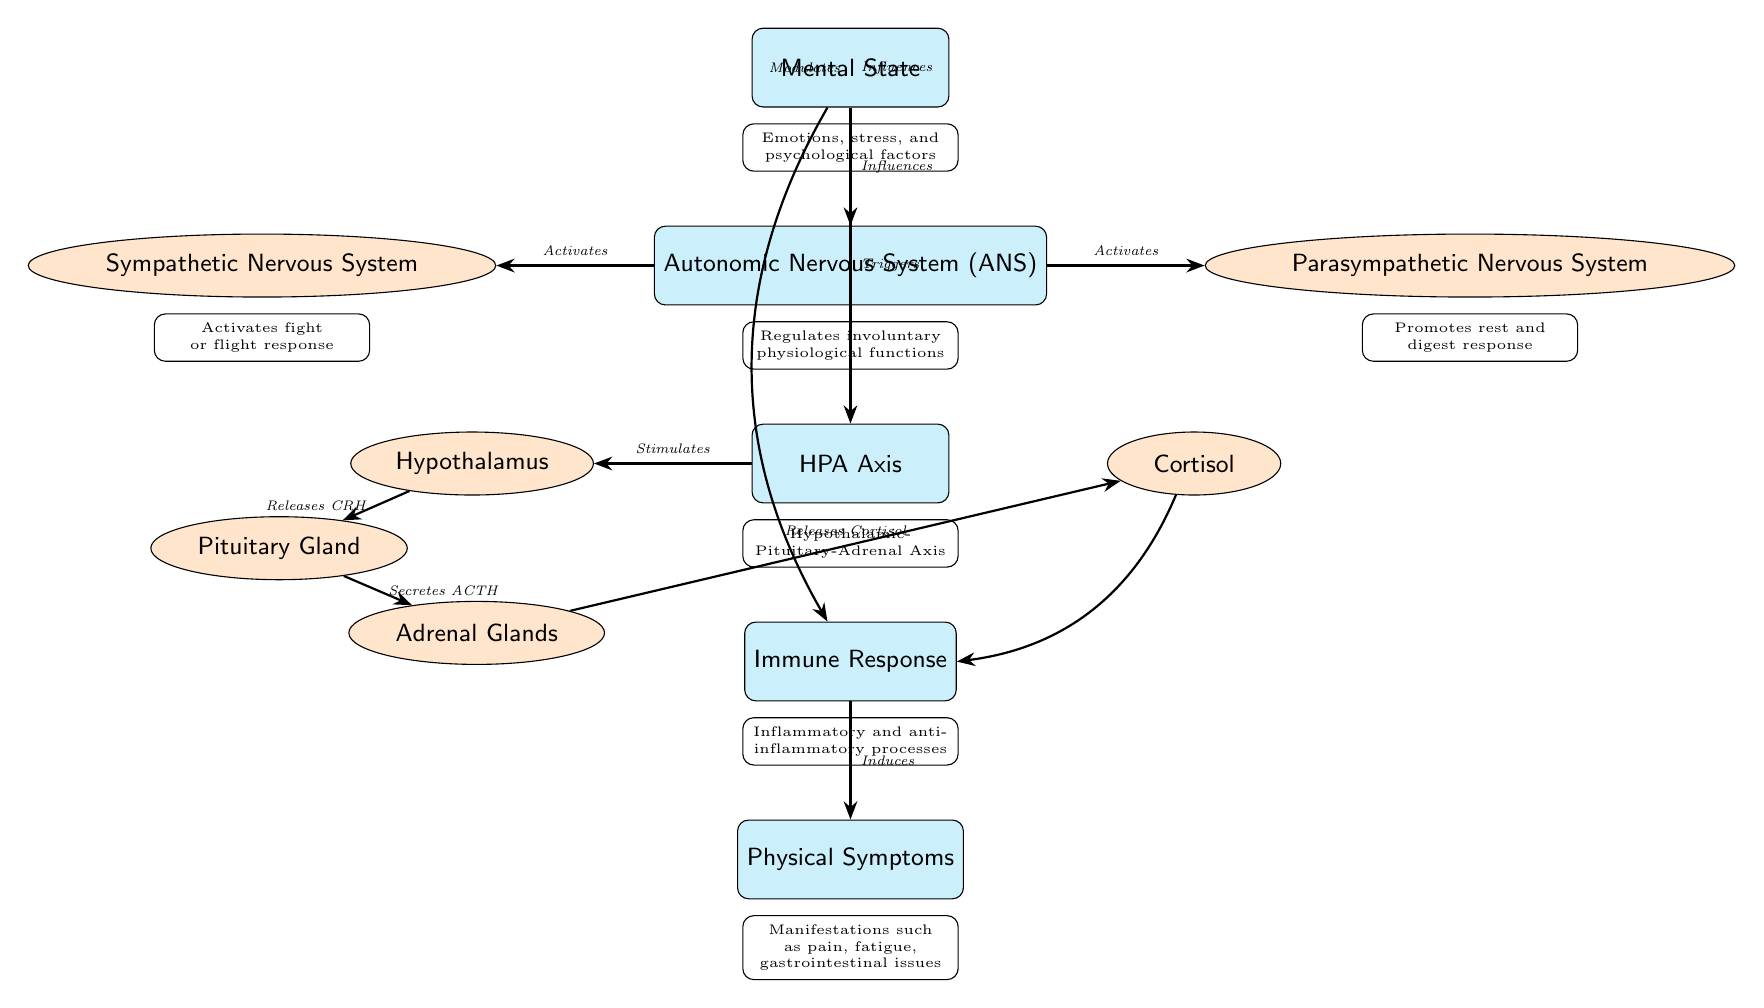What influences the Autonomic Nervous System? The diagram shows an arrow from the Mental State node to the Autonomic Nervous System node, labeled "Influences," indicating that mental states affect the ANS.
Answer: Mental State Which system activates the fight or flight response? Looking at the sub-node of the Autonomic Nervous System, the Sympathetic Nervous System is indicated as activating this response.
Answer: Sympathetic Nervous System What does the HPA axis stimulate? The diagram connects the HPA Axis to the Hypothalamus with a labeled arrow indicating it "Stimulates," suggesting that the HPA axis’s role is to activate the hypothalamus.
Answer: Hypothalamus How do mental states affect immune responses? The diagram shows a curved arrow connecting the Mental State to the Immune Response with the label "Modulates," indicating that mental states can influence or adjust immune functioning.
Answer: Modulates Which gland secretes ACTH? Following the arrows in the diagram, it is clear that ACTH is secreted by the Pituitary Gland as shown in the flow from the Hypothalamus to the Pituitary.
Answer: Pituitary Gland What is the outcome of the immune response on physical symptoms? The diagram shows that the Immune Response induces Physical Symptoms, clearly illustrating a direct connection.
Answer: Induces What hormone is released by the adrenal glands? The diagram specifies that the Adrenal Glands release Cortisol, indicating a straightforward hormonal relationship represented in the flow.
Answer: Cortisol Which branch of the autonomic nervous system promotes rest and digest responses? The diagram identifies the Parasympathetic Nervous System as responsible for promoting this response, as indicated by the related description below the node.
Answer: Parasympathetic Nervous System What type of processes does the immune response regulate? According to the diagram, the immune response is associated with both inflammatory and anti-inflammatory processes, explicitly stated in the description under the Immune Response node.
Answer: Inflammatory and anti-inflammatory processes 